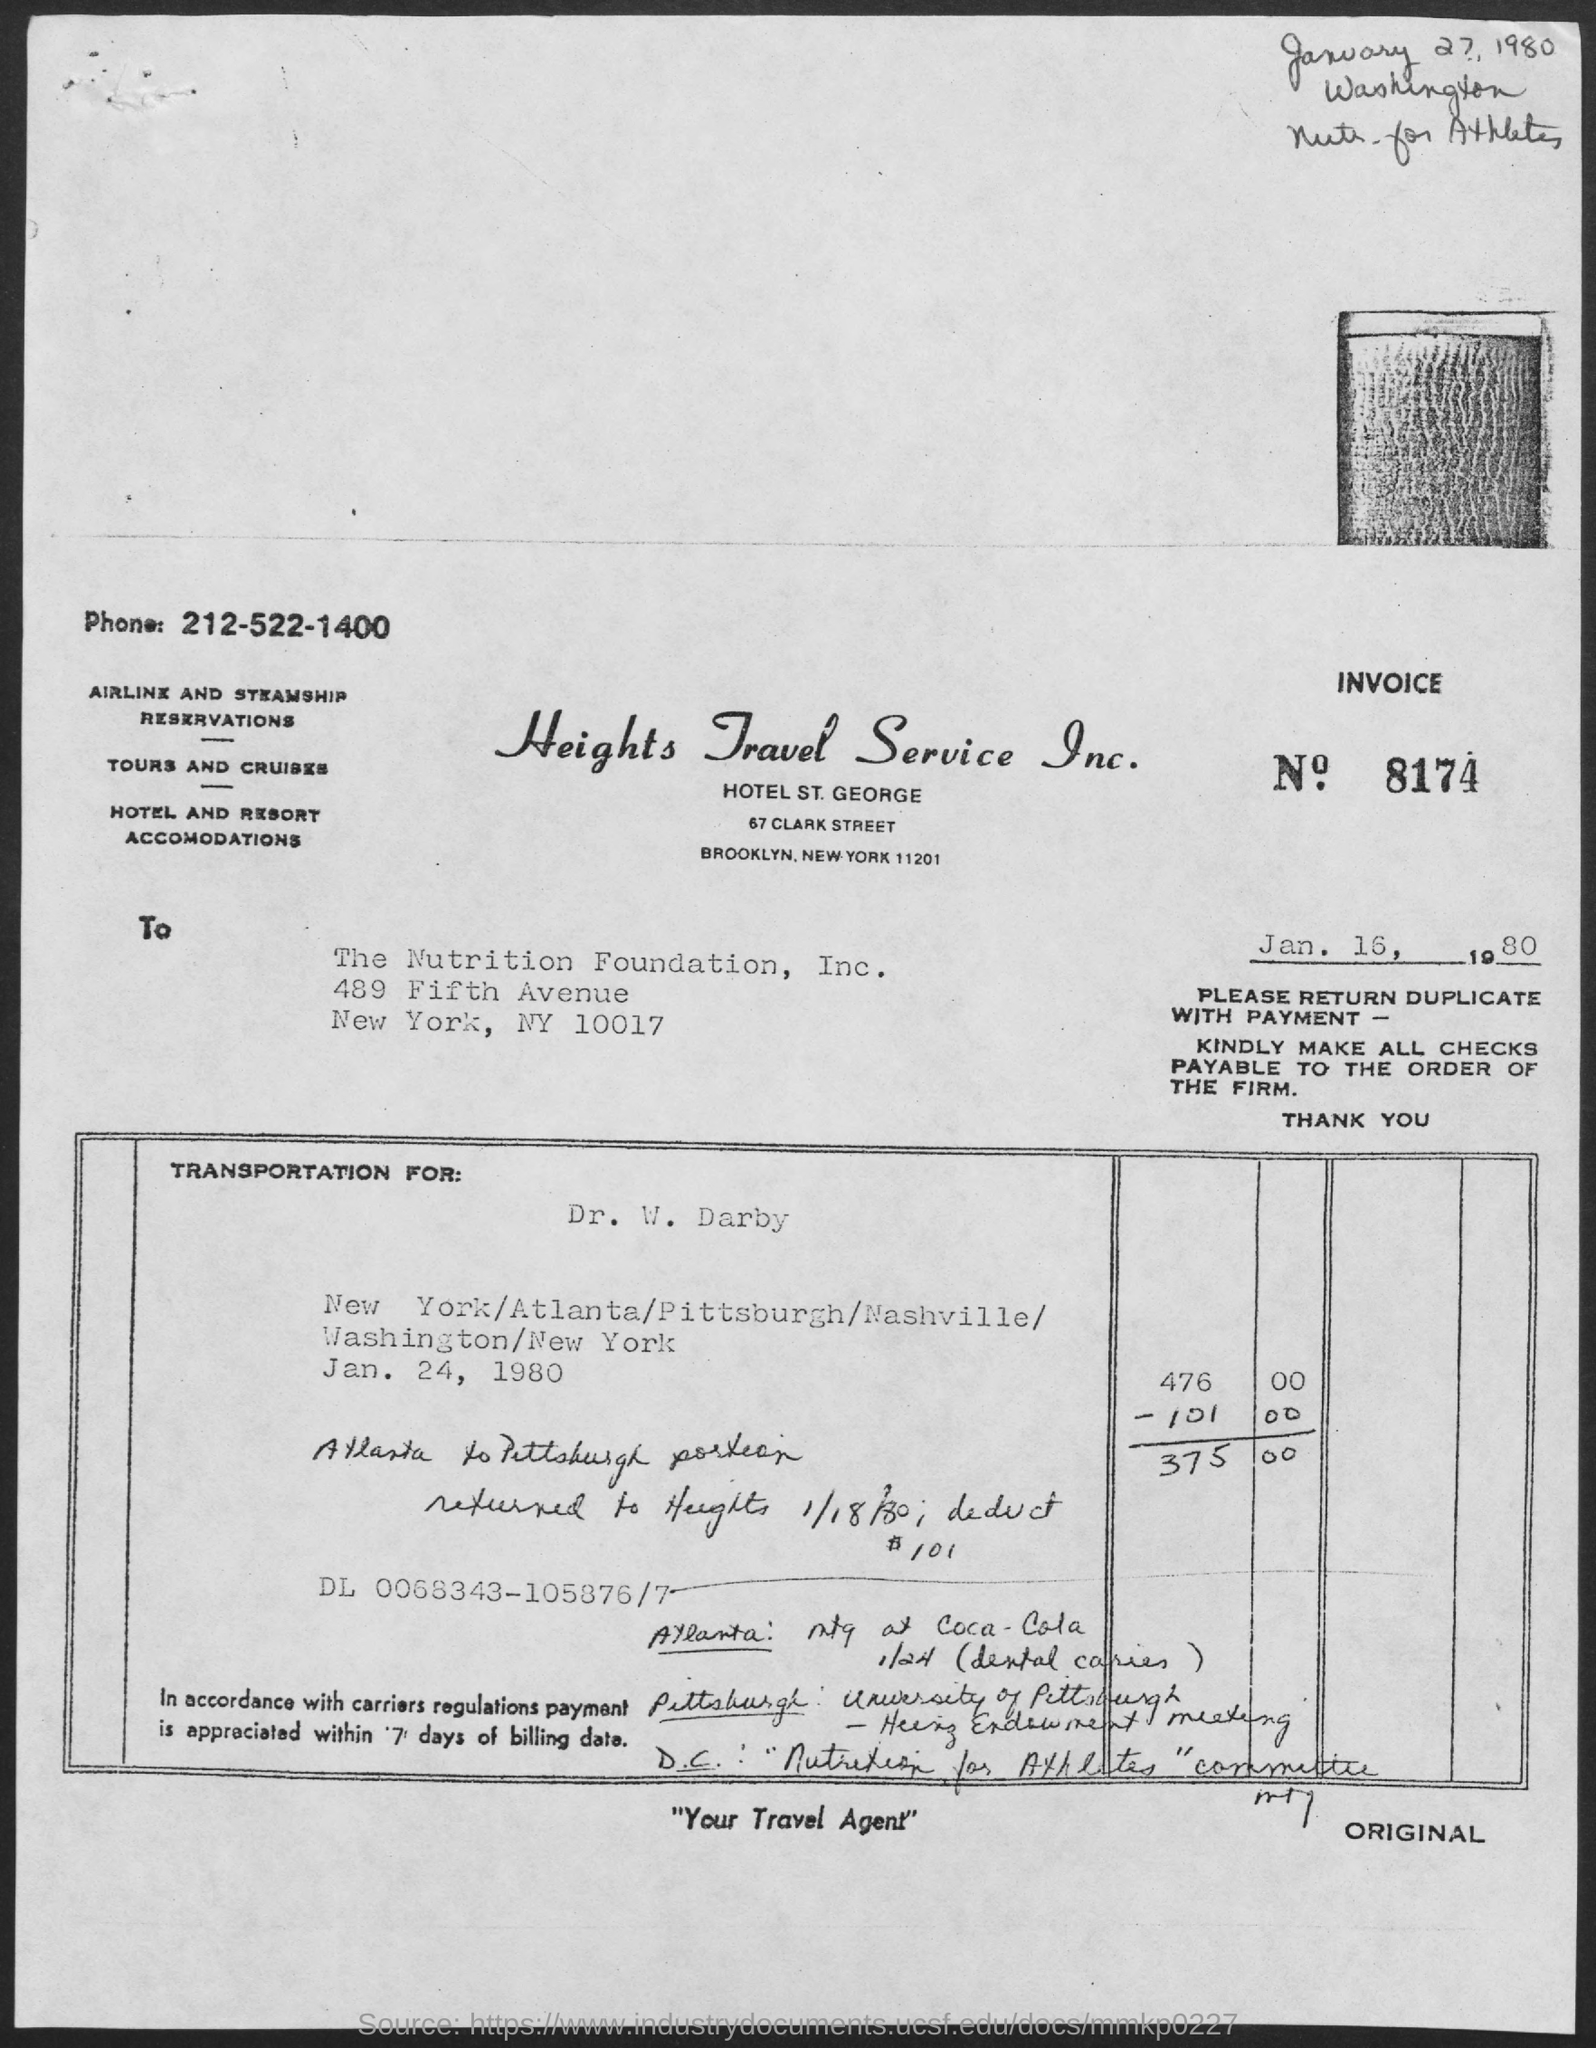List a handful of essential elements in this visual. Heights Travel Service Inc. can be contacted by telephone at 212-522-1400. The tagline of Heights Travel Service Inc. is 'Your travel agent'. The invoice number is 8174. 